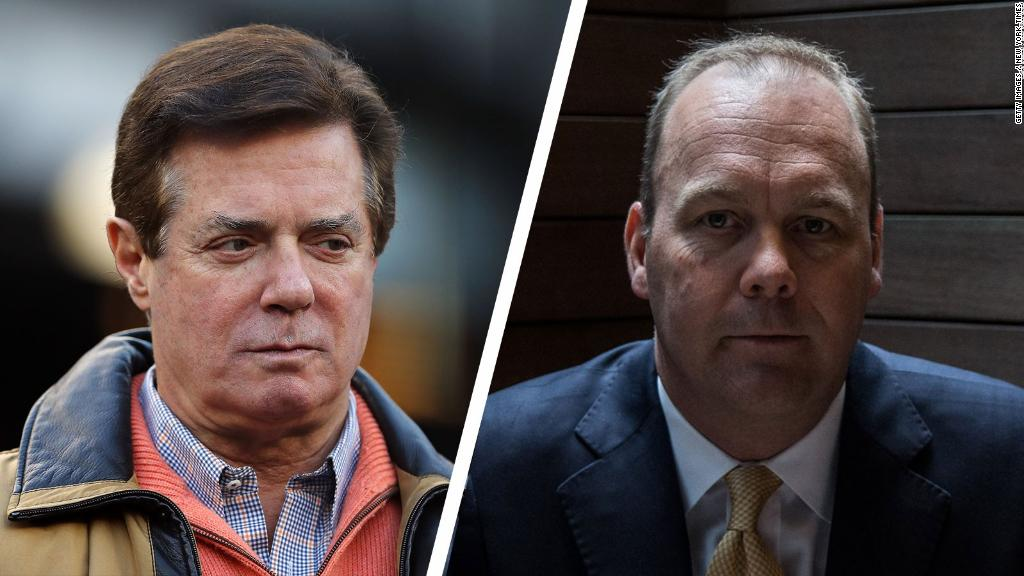Based on their facial expressions, what might these individuals be discussing? Their serious and focused expressions suggest they might be discussing a matter of significant importance. It could be a business deal, a legal issue, or a strategic planning session. The intensity in their gaze hints that the topic is likely complex and requires deep consideration. Could they be planning a major corporate merger? It's quite possible. The man on the right's formal attire and the man on the left's smart-casual appearance could signify roles such as a CEO and a high-ranking executive. Their serious expressions and composed demeanor support the idea of discussing a high-stakes corporate merger. 